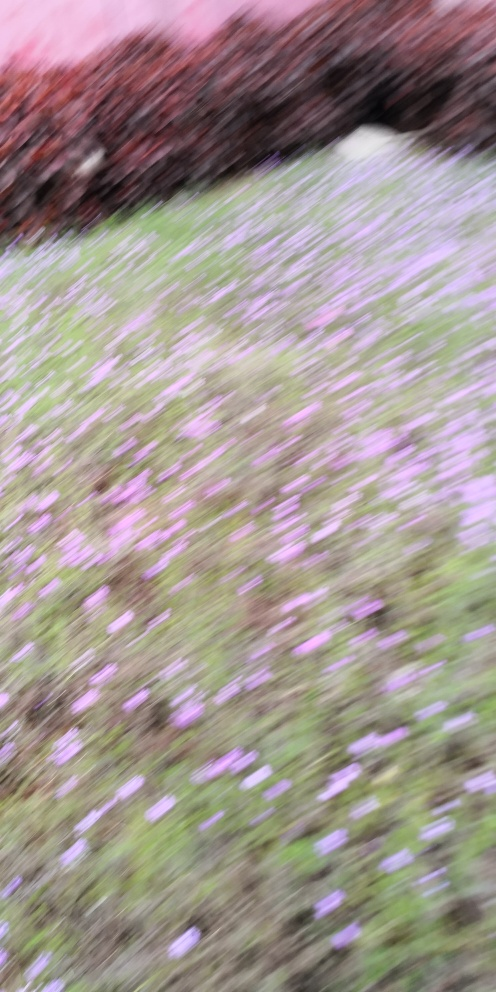Is the quality of the image very poor? The quality of the image appears to be compromised due to motion blur and lack of focus, which obscures the details and subjects within the photograph. 